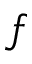Convert formula to latex. <formula><loc_0><loc_0><loc_500><loc_500>f</formula> 